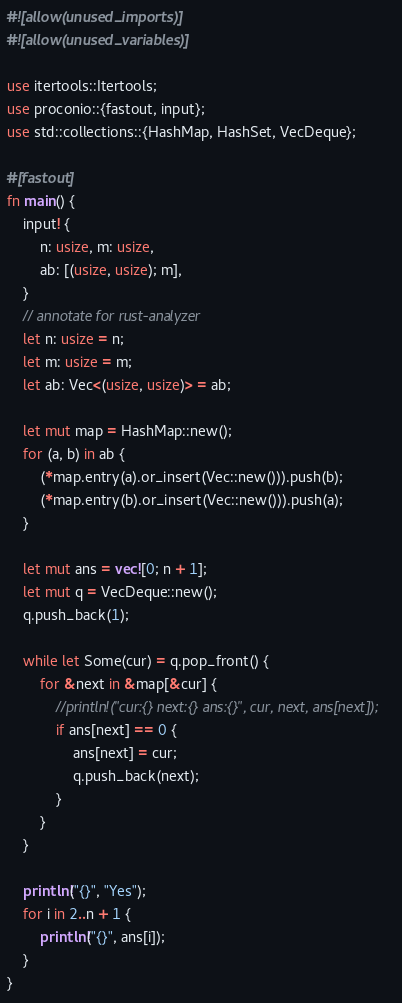<code> <loc_0><loc_0><loc_500><loc_500><_Rust_>#![allow(unused_imports)]
#![allow(unused_variables)]

use itertools::Itertools;
use proconio::{fastout, input};
use std::collections::{HashMap, HashSet, VecDeque};

#[fastout]
fn main() {
    input! {
        n: usize, m: usize,
        ab: [(usize, usize); m],
    }
    // annotate for rust-analyzer
    let n: usize = n;
    let m: usize = m;
    let ab: Vec<(usize, usize)> = ab;

    let mut map = HashMap::new();
    for (a, b) in ab {
        (*map.entry(a).or_insert(Vec::new())).push(b);
        (*map.entry(b).or_insert(Vec::new())).push(a);
    }

    let mut ans = vec![0; n + 1];
    let mut q = VecDeque::new();
    q.push_back(1);

    while let Some(cur) = q.pop_front() {
        for &next in &map[&cur] {
            //println!("cur:{} next:{} ans:{}", cur, next, ans[next]);
            if ans[next] == 0 {
                ans[next] = cur;
                q.push_back(next);
            }
        }
    }

    println!("{}", "Yes");
    for i in 2..n + 1 {
        println!("{}", ans[i]);
    }
}
</code> 